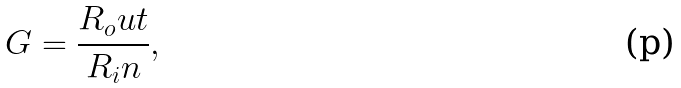Convert formula to latex. <formula><loc_0><loc_0><loc_500><loc_500>G = \frac { R _ { o } u t } { R _ { i } n } ,</formula> 